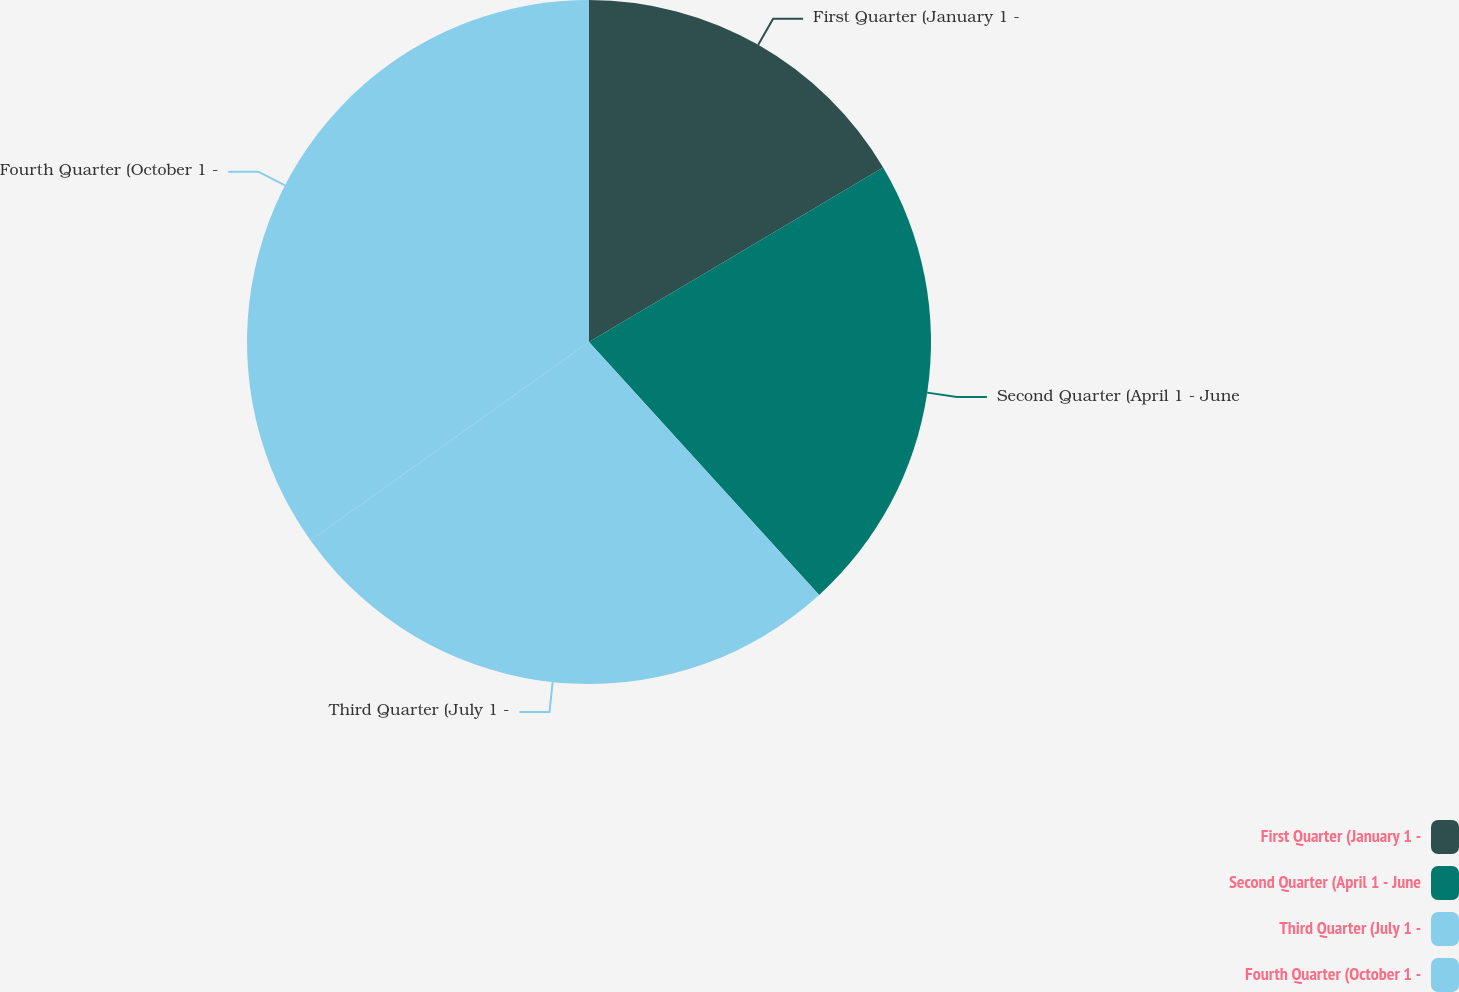<chart> <loc_0><loc_0><loc_500><loc_500><pie_chart><fcel>First Quarter (January 1 -<fcel>Second Quarter (April 1 - June<fcel>Third Quarter (July 1 -<fcel>Fourth Quarter (October 1 -<nl><fcel>16.48%<fcel>21.77%<fcel>26.89%<fcel>34.86%<nl></chart> 